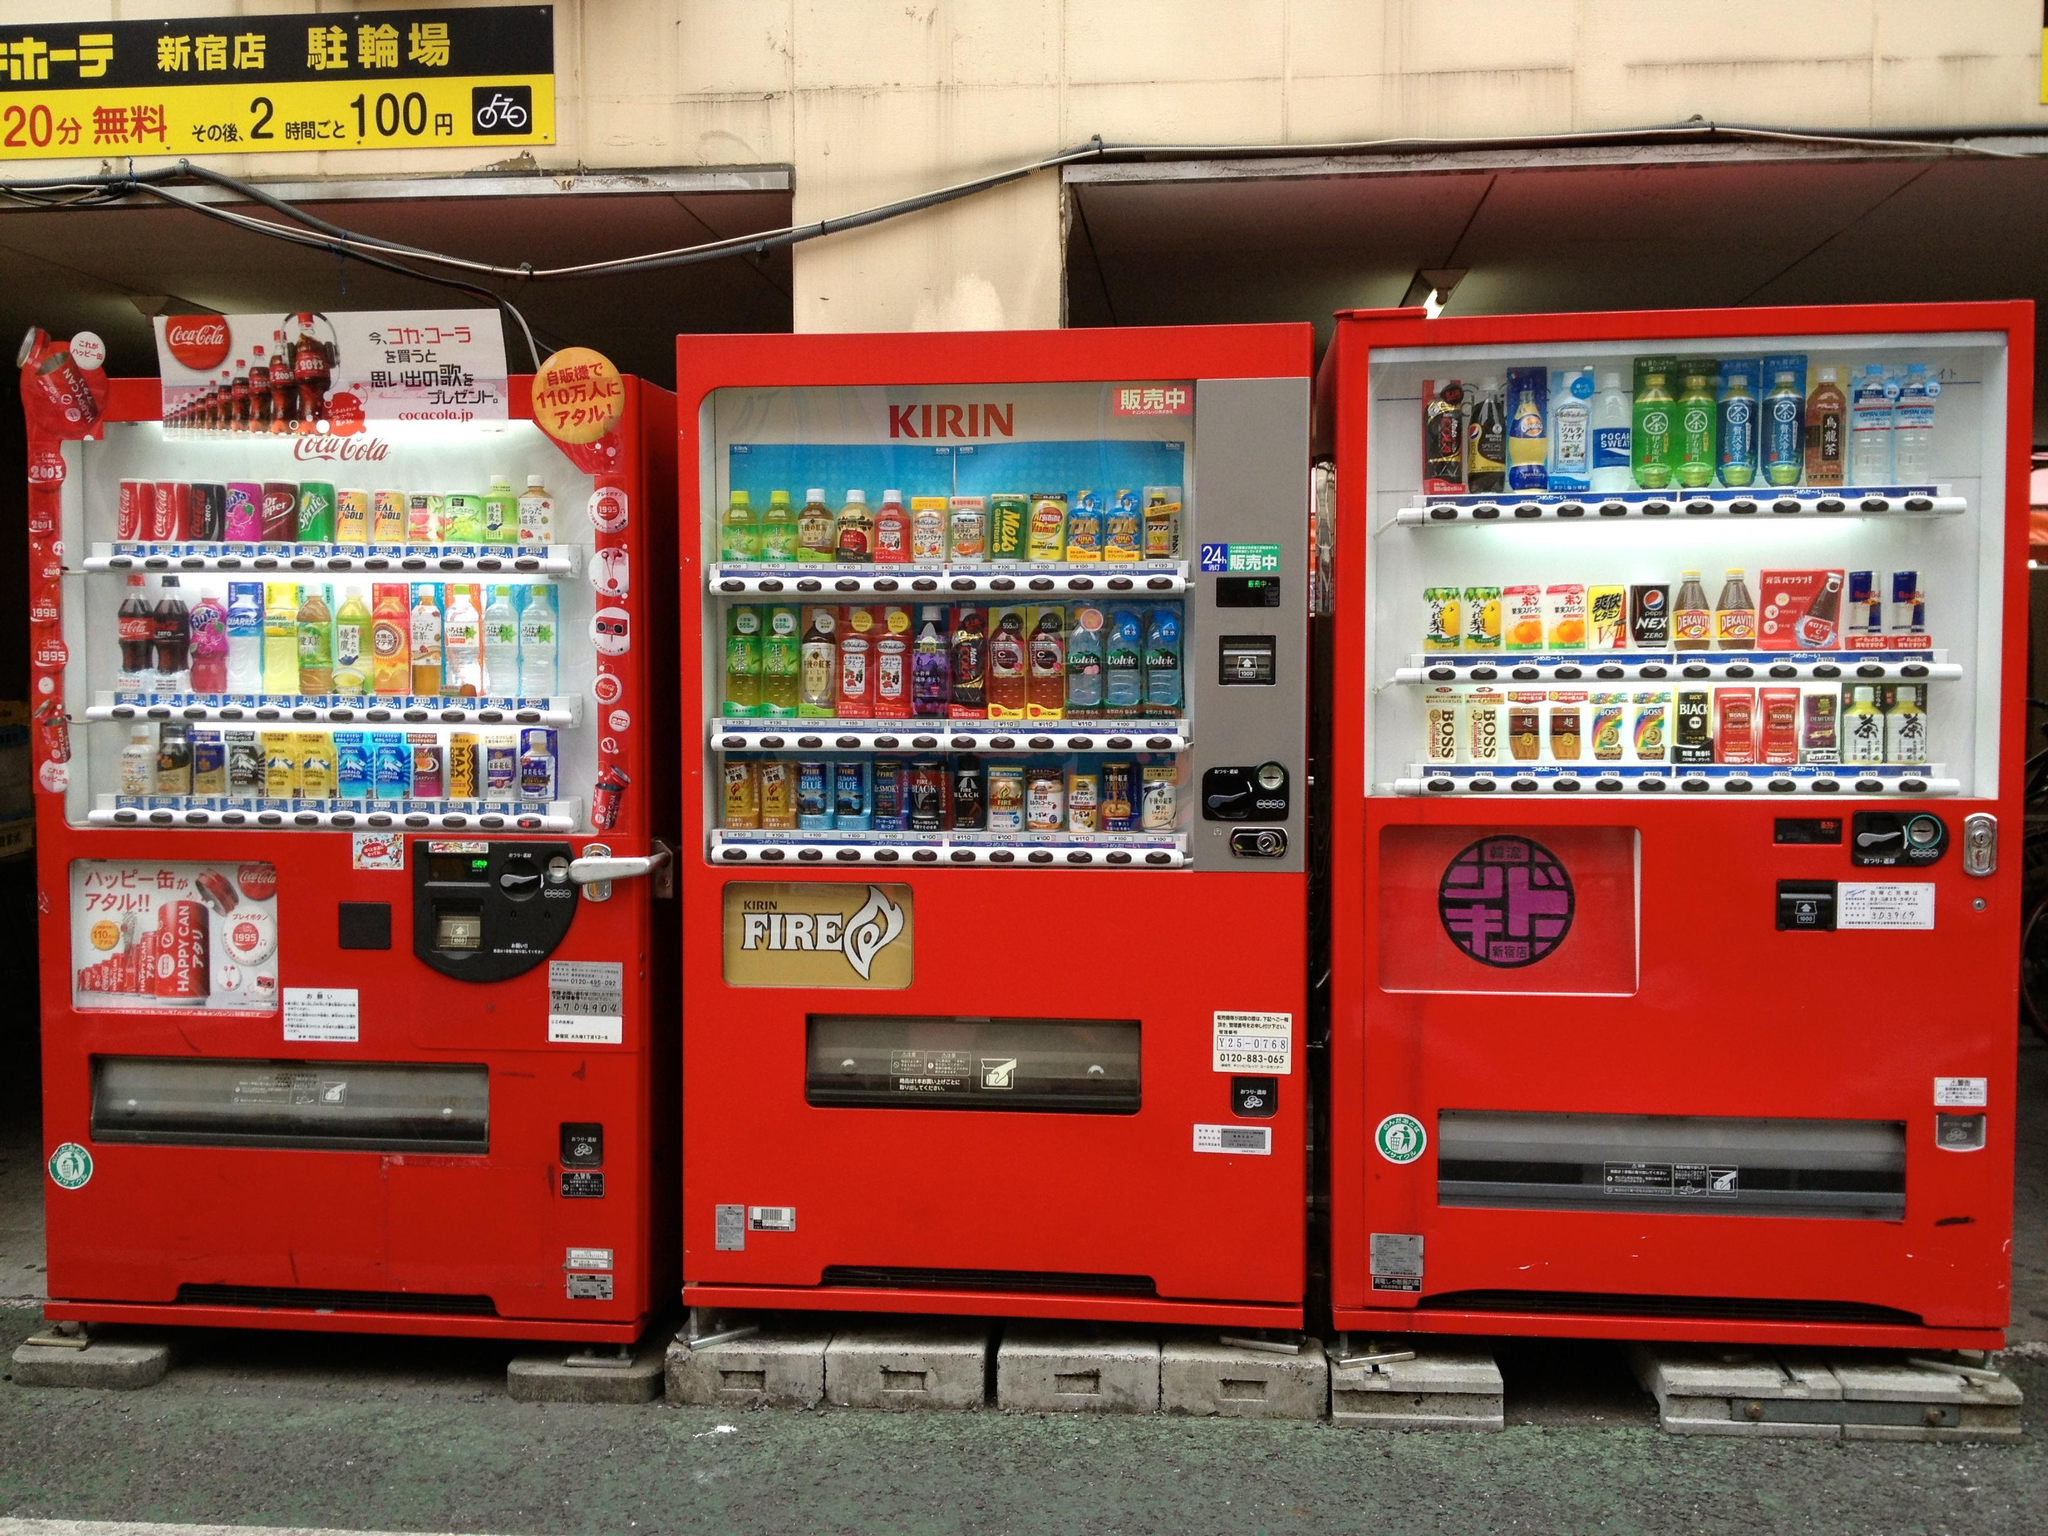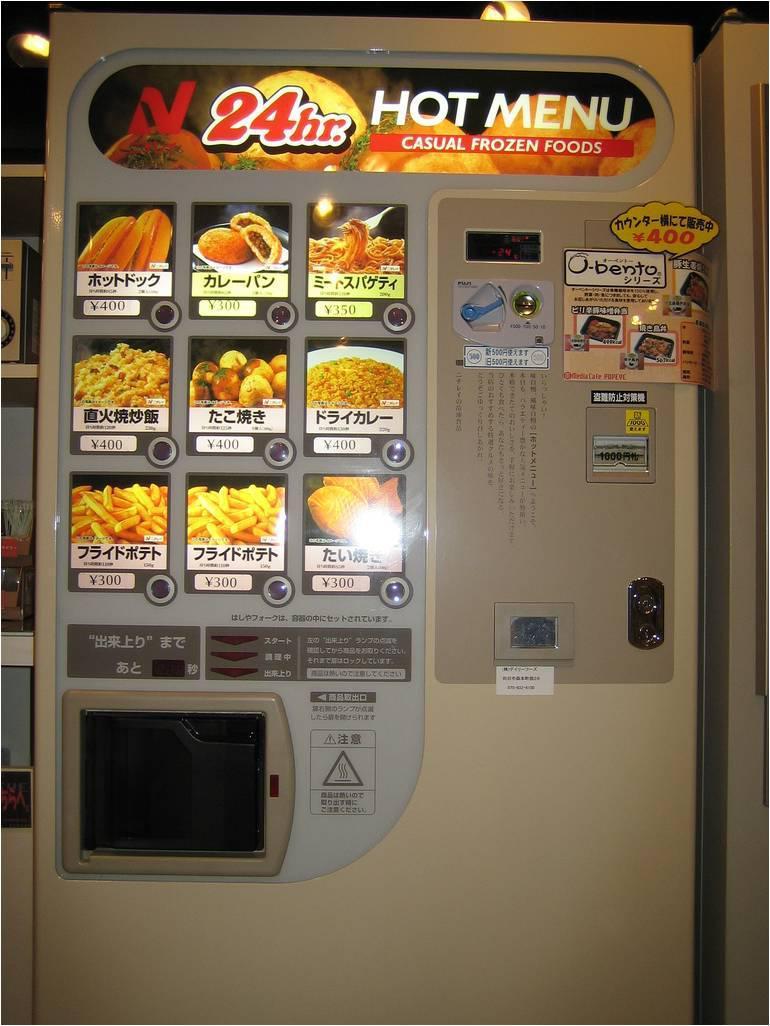The first image is the image on the left, the second image is the image on the right. For the images displayed, is the sentence "An image shows a single vending machine, which offers meal-type options." factually correct? Answer yes or no. Yes. 